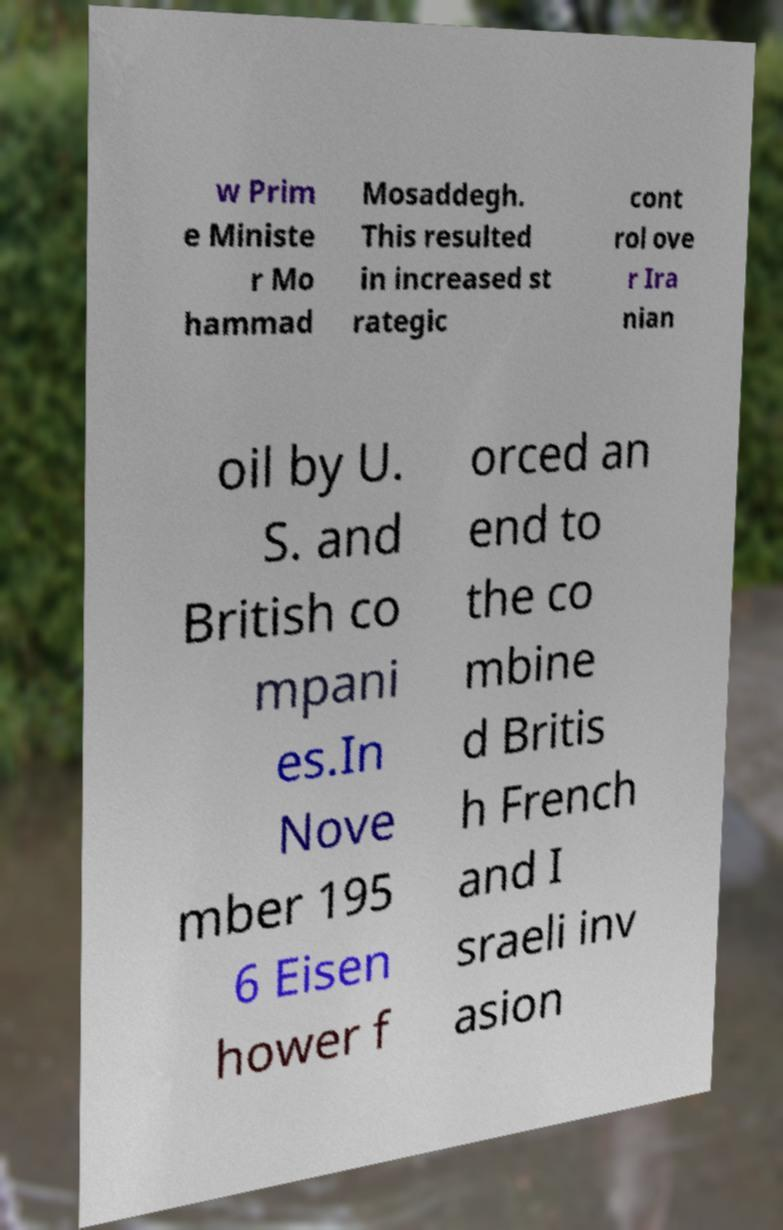Please identify and transcribe the text found in this image. w Prim e Ministe r Mo hammad Mosaddegh. This resulted in increased st rategic cont rol ove r Ira nian oil by U. S. and British co mpani es.In Nove mber 195 6 Eisen hower f orced an end to the co mbine d Britis h French and I sraeli inv asion 